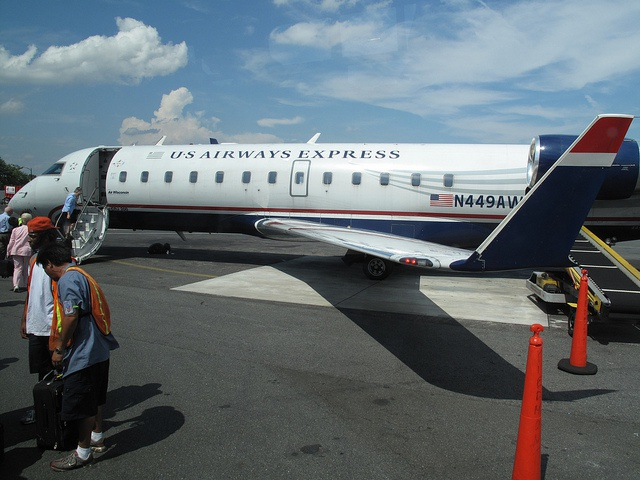Describe the objects in this image and their specific colors. I can see airplane in blue, lightgray, black, darkgray, and gray tones, people in blue, black, gray, and maroon tones, people in blue, black, darkgray, and maroon tones, suitcase in blue, black, gray, olive, and purple tones, and people in blue, gray, darkgray, black, and pink tones in this image. 